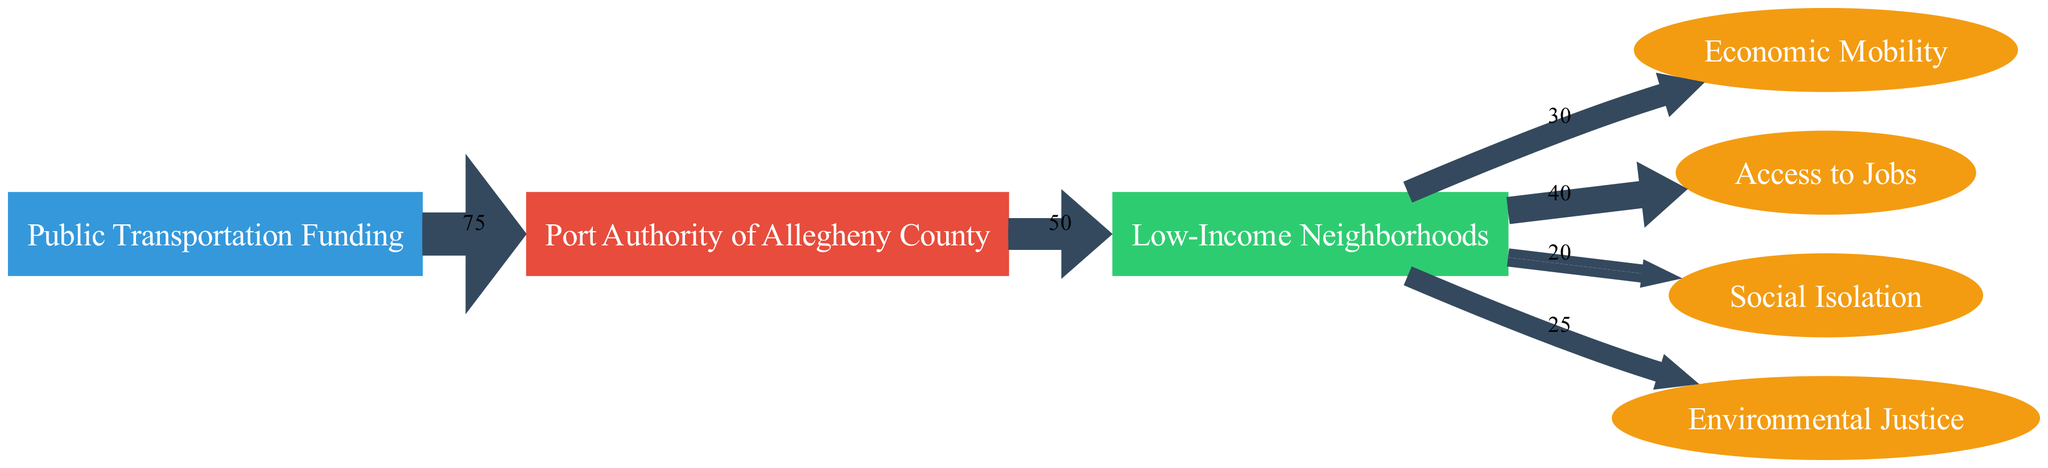What is the total public transportation funding allocated? The diagram shows that the total public transportation funding allocated is represented by the link from "Public Transportation Funding" to "Port Authority of Allegheny County," which has a value of 75.
Answer: 75 How much funding goes from the Port Authority to low-income neighborhoods? The link from "Port Authority of Allegheny County" to "Low-Income Neighborhoods" indicates a funding amount of 50.
Answer: 50 What is the impact funding for Economic Mobility from low-income neighborhoods? The link from "Low-Income Neighborhoods" to "Economic Mobility" shows an impact funding value of 30.
Answer: 30 Which impact category receives the highest value from low-income neighborhoods? By comparing the values of the impacts stemming from "Low-Income Neighborhoods," the highest value is for "Access to Jobs," which has a value of 40.
Answer: Access to Jobs How many nodes are there in the diagram? By counting, there are six distinct nodes listed: "Public Transportation Funding," "Port Authority of Allegheny County," "Low-Income Neighborhoods," "Economic Mobility," "Access to Jobs," "Social Isolation," and "Environmental Justice."
Answer: 6 What is the total impact value from low-income neighborhoods? To calculate the total impact, sum the values of all impacts: Economic Mobility (30), Access to Jobs (40), Social Isolation (20), and Environmental Justice (25). This results in a total impact value of 115.
Answer: 115 How does the funding flow from the source to low-income neighborhoods? The flow starts from "Public Transportation Funding" which distributes 75 to "Port Authority of Allegheny County," which in turn allocates 50 to "Low-Income Neighborhoods."
Answer: 75 to 50 Which impacts are associated with low-income neighborhoods? The impacts associated with low-income neighborhoods, indicated by the outgoing links, are Economic Mobility, Access to Jobs, Social Isolation, and Environmental Justice, showcasing the diverse impacts of the funding.
Answer: Economic Mobility, Access to Jobs, Social Isolation, Environmental Justice What is the value assigned to Social Isolation as an impact? The link from "Low-Income Neighborhoods" to "Social Isolation" shows that the assigned value is 20.
Answer: 20 